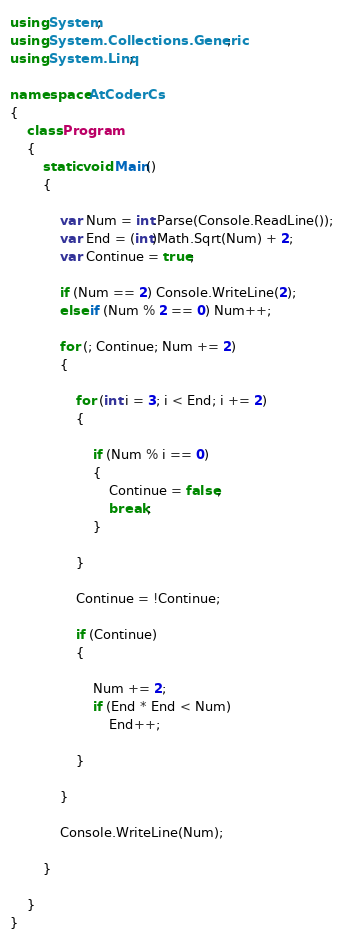Convert code to text. <code><loc_0><loc_0><loc_500><loc_500><_C#_>using System;
using System.Collections.Generic;
using System.Linq;

namespace AtCoderCs
{
    class Program
    {
        static void Main()
        {

            var Num = int.Parse(Console.ReadLine());
            var End = (int)Math.Sqrt(Num) + 2;
            var Continue = true;

            if (Num == 2) Console.WriteLine(2);
            else if (Num % 2 == 0) Num++;

            for (; Continue; Num += 2)
            {

                for (int i = 3; i < End; i += 2)
                {

                    if (Num % i == 0)
                    {
                        Continue = false;
                        break;
                    }

                }

                Continue = !Continue;

                if (Continue)
                {

                    Num += 2;
                    if (End * End < Num)
                        End++;

                }

            }

            Console.WriteLine(Num);

        }

    }
}
</code> 